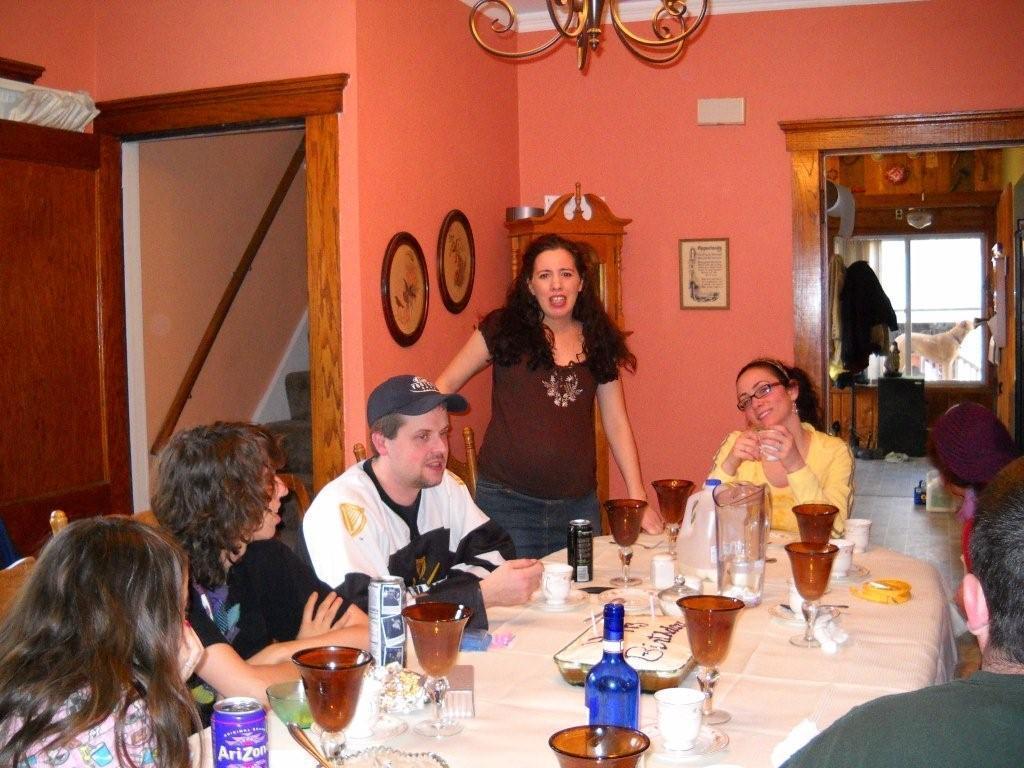Could you give a brief overview of what you see in this image? in this image i can see a group persons sitting on the chair and her mouth was open and there are the photo frames attached to the wall and stair case on the house. there is a window on the right corner ,through window i can see a dog 